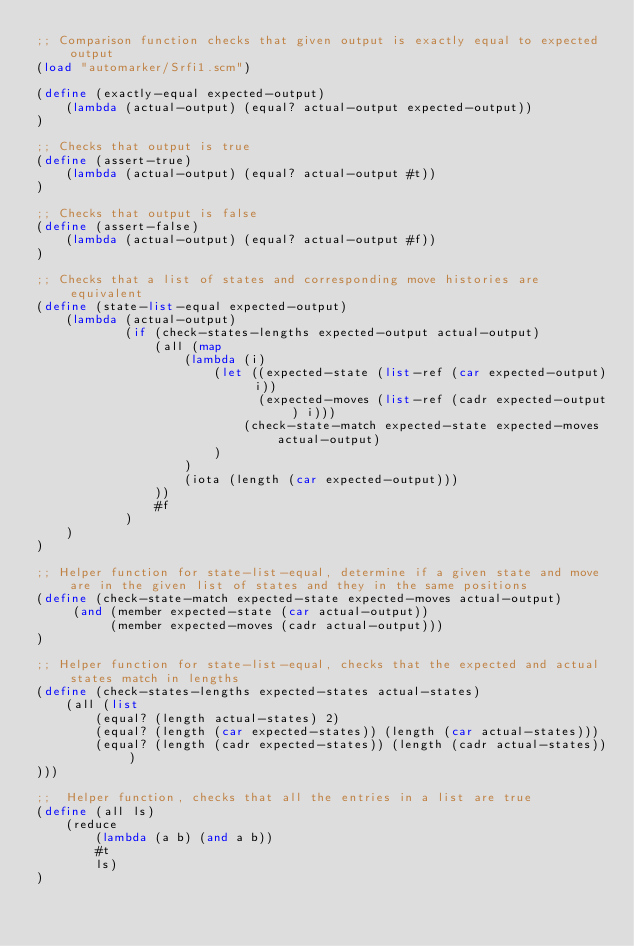<code> <loc_0><loc_0><loc_500><loc_500><_Scheme_>;; Comparison function checks that given output is exactly equal to expected output
(load "automarker/Srfi1.scm")

(define (exactly-equal expected-output)
    (lambda (actual-output) (equal? actual-output expected-output))
)

;; Checks that output is true
(define (assert-true)
    (lambda (actual-output) (equal? actual-output #t))
)

;; Checks that output is false
(define (assert-false)
    (lambda (actual-output) (equal? actual-output #f))
)

;; Checks that a list of states and corresponding move histories are equivalent
(define (state-list-equal expected-output)
    (lambda (actual-output)
            (if (check-states-lengths expected-output actual-output)
                (all (map 
                    (lambda (i)
                        (let ((expected-state (list-ref (car expected-output) i))
                              (expected-moves (list-ref (cadr expected-output) i)))
                            (check-state-match expected-state expected-moves actual-output) 
                        )
                    )
                    (iota (length (car expected-output)))
                ))              
                #f
            )
    )
)

;; Helper function for state-list-equal, determine if a given state and move are in the given list of states and they in the same positions
(define (check-state-match expected-state expected-moves actual-output)
     (and (member expected-state (car actual-output))
          (member expected-moves (cadr actual-output)))
)

;; Helper function for state-list-equal, checks that the expected and actual states match in lengths
(define (check-states-lengths expected-states actual-states)
    (all (list 
        (equal? (length actual-states) 2)
        (equal? (length (car expected-states)) (length (car actual-states)))
        (equal? (length (cadr expected-states)) (length (cadr actual-states)))
)))

;;  Helper function, checks that all the entries in a list are true
(define (all ls)
    (reduce 
        (lambda (a b) (and a b))
        #t
        ls)
)
</code> 